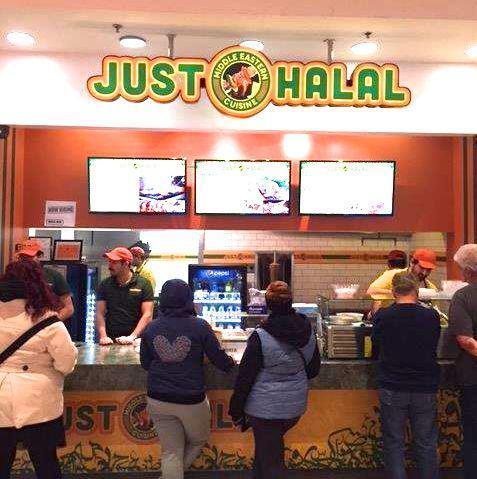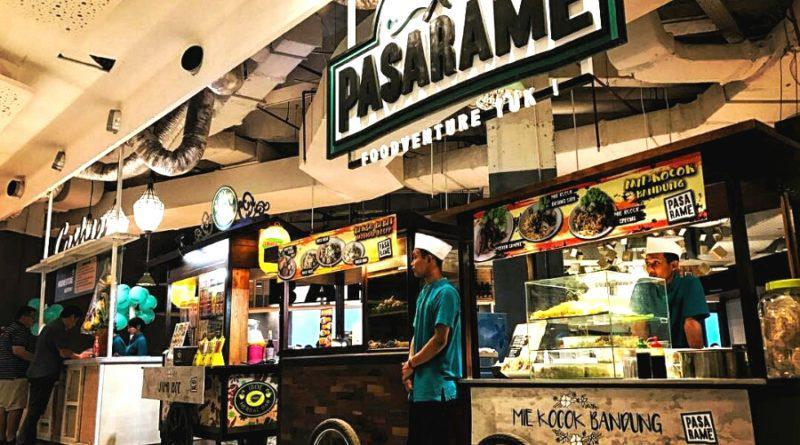The first image is the image on the left, the second image is the image on the right. Analyze the images presented: Is the assertion "An unoccupied table sits near a restaurant in one of the images." valid? Answer yes or no. No. The first image is the image on the left, the second image is the image on the right. Considering the images on both sides, is "The lights in the image on the left are hanging above the counter." valid? Answer yes or no. No. 